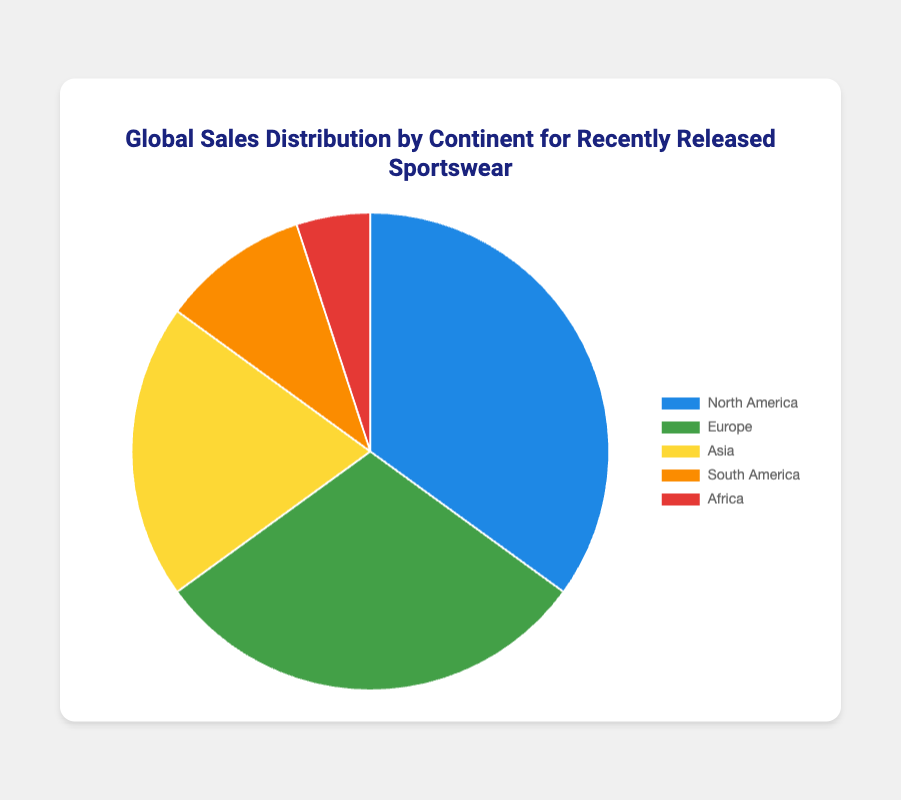What is the total percentage of sales for North America and Europe? To find the total percentage of sales for North America and Europe, add the sales percentages of these two continents: 35% (North America) + 30% (Europe) = 65%.
Answer: 65% Which continent has the third highest sales percentage? By looking at the sales percentages, we can see that North America has 35%, Europe has 30%, and Asia has 20%. Therefore, Asia has the third highest sales percentage after North America and Europe.
Answer: Asia Is the sales percentage in North America greater than the combined sales percentages of South America and Africa? Compare the sales percentage of North America (35%) with the combined sales percentages of South America (10%) and Africa (5%). 10% + 5% = 15%, and 35% is greater than 15%.
Answer: Yes What is the difference in sales percentage between North America and Asia? Subtract the sales percentage of Asia (20%) from the sales percentage of North America (35%): 35% - 20% = 15%.
Answer: 15% Which continent is represented by the green color in the figure? By looking at the color legend, we can see that Europe is represented by the green color.
Answer: Europe Which two continents combined have the lowest sales percentage? Look at the sales percentages for all the continents: North America (35%), Europe (30%), Asia (20%), South America (10%), and Africa (5%). The combination of South America and Africa gives the lowest combined percentage: 10% + 5% = 15%.
Answer: South America and Africa Is the sales percentage of Europe exactly equal to the sales percentage of North America, Africa, and South America combined? Add the sales percentages of North America (35%), Africa (5%), and South America (10%): 35% + 5% + 10% = 50%. Since 50% is greater than Europe's 30%, they are not equal.
Answer: No What's the least popular continent for the recently released sportswear? The least popular continent is the one with the smallest percentage. Africa has the smallest sales percentage at 5%.
Answer: Africa If the percentage needs to be divided by two regions, where Asia and all other continents that don't include Asia are in separate regions, which region has the higher sales percentage? Asia has a sales percentage of 20%. The combined sales percentage of the other continents (North America, Europe, South America, Africa) is 35% + 30% + 10% + 5% = 80%. Thus, the region excluding Asia has the higher percentage.
Answer: The region excluding Asia How many continents have a sales percentage that is at least twice that of Africa? Africa has a sales percentage of 5%. To be at least twice as much means having at least 10%. North America (35%), Europe (30%), and Asia (20%) all meet this criterion. Thus, 3 continents meet this criterion.
Answer: 3 